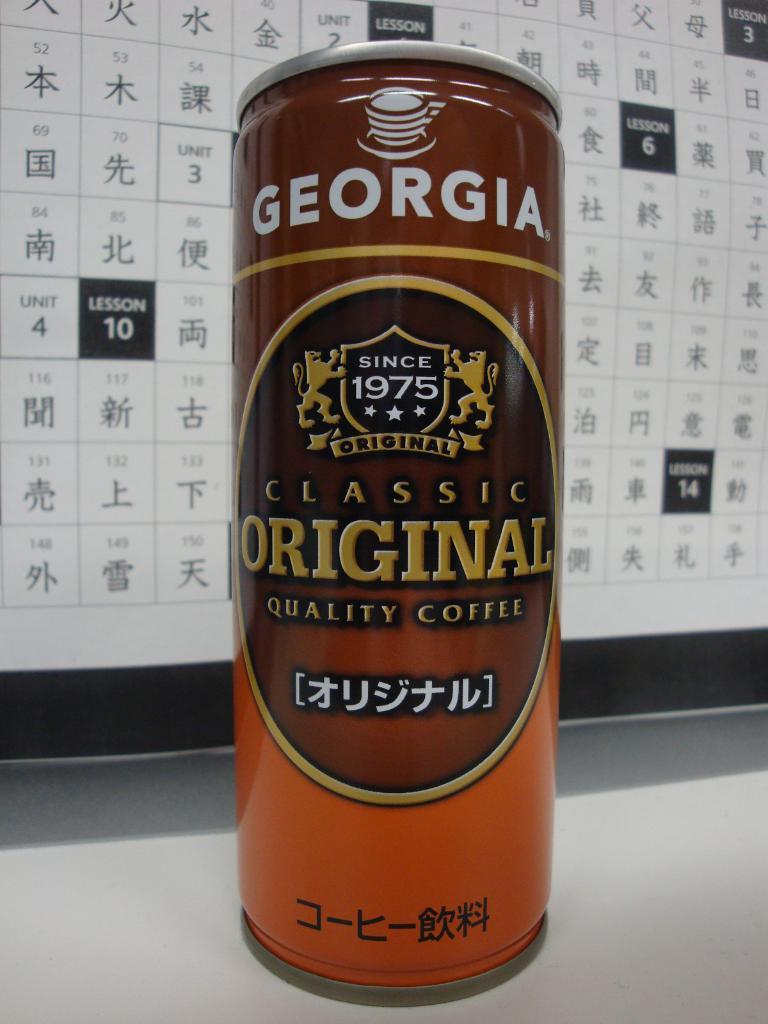What beverage is this georgia drink?
Your answer should be very brief. Coffee. What year is noted on the front of this can?
Keep it short and to the point. 1975. 